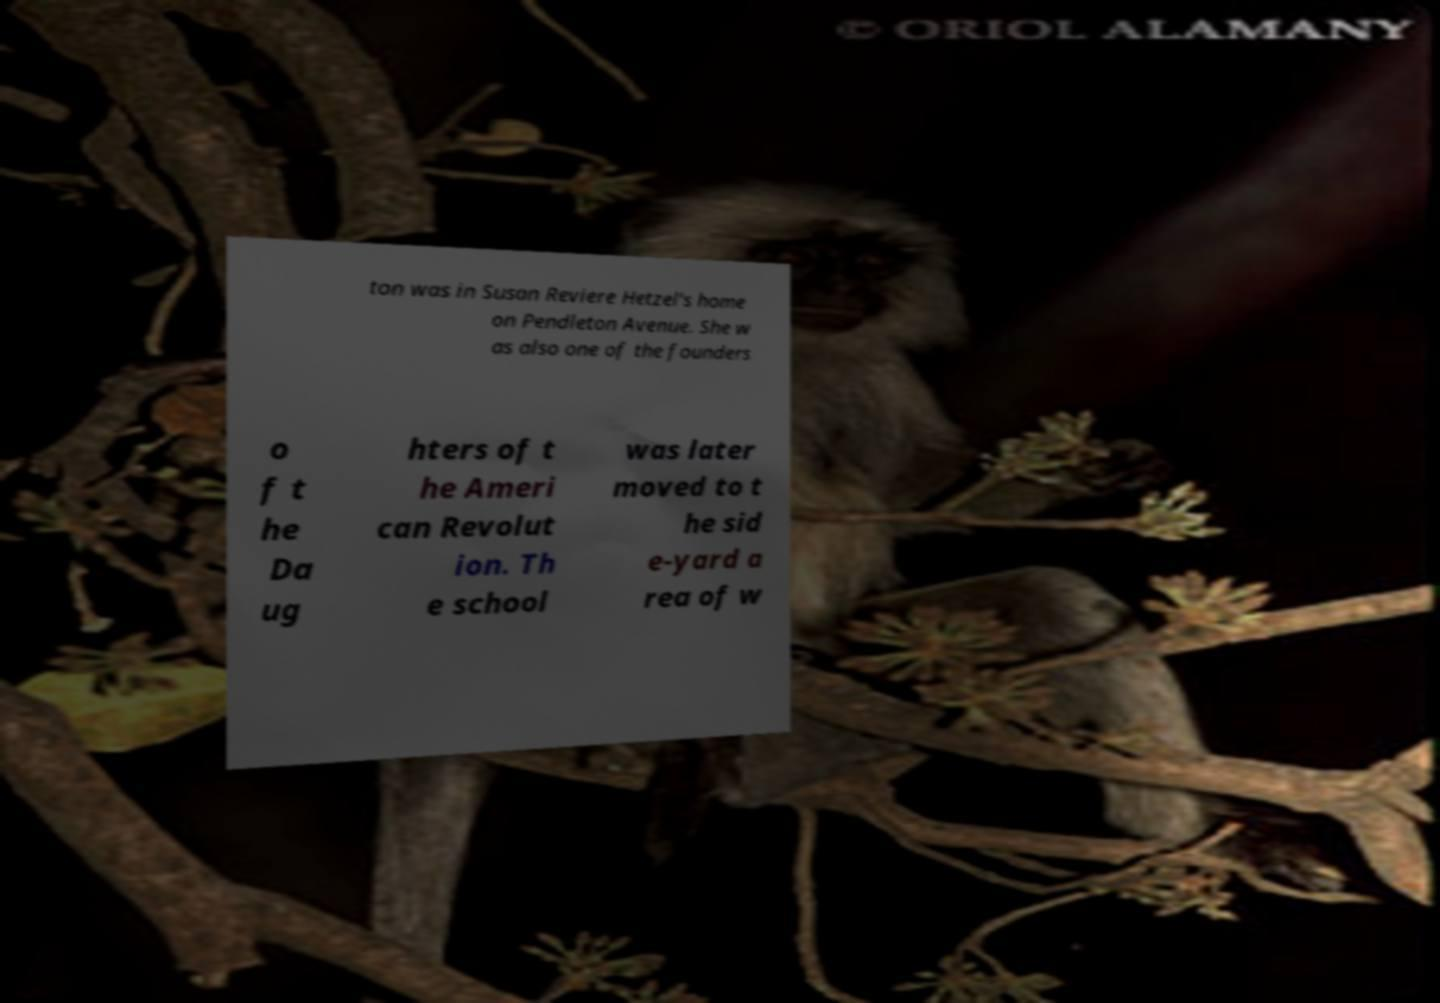Could you assist in decoding the text presented in this image and type it out clearly? ton was in Susan Reviere Hetzel's home on Pendleton Avenue. She w as also one of the founders o f t he Da ug hters of t he Ameri can Revolut ion. Th e school was later moved to t he sid e-yard a rea of w 